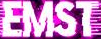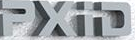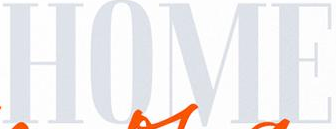What text is displayed in these images sequentially, separated by a semicolon? EMST; PXiD; HOME 